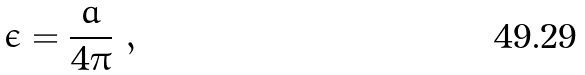Convert formula to latex. <formula><loc_0><loc_0><loc_500><loc_500>\epsilon = \frac { a } { 4 \pi } \ ,</formula> 